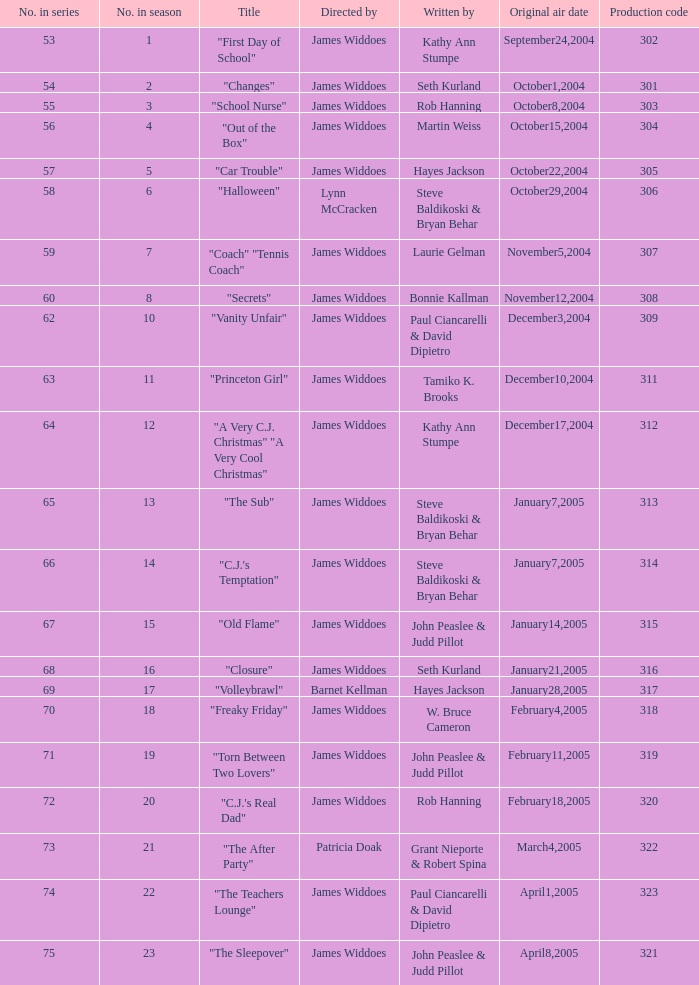What is the manufacturing code for episode 3 of the season? 303.0. 